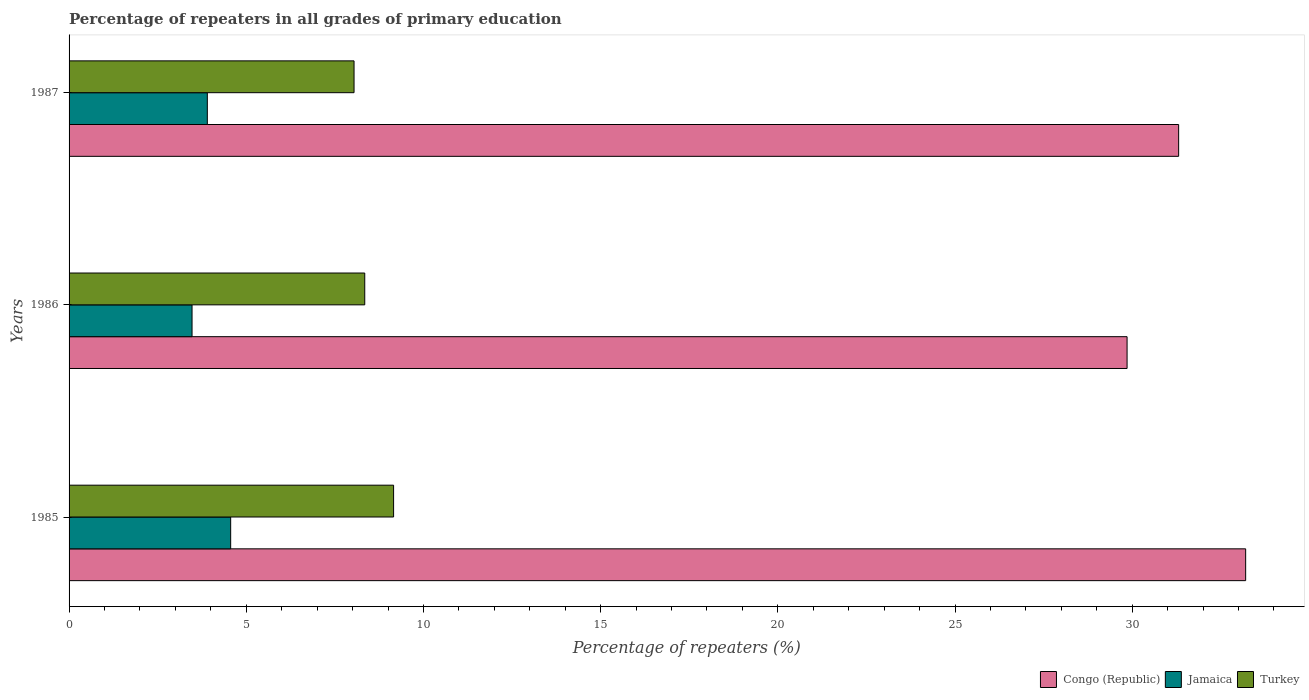How many groups of bars are there?
Provide a short and direct response. 3. Are the number of bars per tick equal to the number of legend labels?
Offer a terse response. Yes. In how many cases, is the number of bars for a given year not equal to the number of legend labels?
Your answer should be very brief. 0. What is the percentage of repeaters in Jamaica in 1986?
Give a very brief answer. 3.47. Across all years, what is the maximum percentage of repeaters in Turkey?
Give a very brief answer. 9.16. Across all years, what is the minimum percentage of repeaters in Turkey?
Offer a very short reply. 8.04. In which year was the percentage of repeaters in Turkey maximum?
Give a very brief answer. 1985. In which year was the percentage of repeaters in Congo (Republic) minimum?
Ensure brevity in your answer.  1986. What is the total percentage of repeaters in Jamaica in the graph?
Offer a terse response. 11.93. What is the difference between the percentage of repeaters in Congo (Republic) in 1986 and that in 1987?
Offer a very short reply. -1.46. What is the difference between the percentage of repeaters in Turkey in 1987 and the percentage of repeaters in Jamaica in 1986?
Your answer should be compact. 4.57. What is the average percentage of repeaters in Jamaica per year?
Offer a terse response. 3.98. In the year 1987, what is the difference between the percentage of repeaters in Turkey and percentage of repeaters in Jamaica?
Give a very brief answer. 4.14. In how many years, is the percentage of repeaters in Congo (Republic) greater than 22 %?
Your answer should be compact. 3. What is the ratio of the percentage of repeaters in Congo (Republic) in 1985 to that in 1986?
Your response must be concise. 1.11. What is the difference between the highest and the second highest percentage of repeaters in Congo (Republic)?
Provide a succinct answer. 1.89. What is the difference between the highest and the lowest percentage of repeaters in Jamaica?
Give a very brief answer. 1.09. What does the 1st bar from the top in 1987 represents?
Offer a terse response. Turkey. What does the 1st bar from the bottom in 1987 represents?
Your response must be concise. Congo (Republic). Is it the case that in every year, the sum of the percentage of repeaters in Turkey and percentage of repeaters in Congo (Republic) is greater than the percentage of repeaters in Jamaica?
Your answer should be compact. Yes. How many bars are there?
Your answer should be compact. 9. How many years are there in the graph?
Ensure brevity in your answer.  3. What is the difference between two consecutive major ticks on the X-axis?
Keep it short and to the point. 5. Does the graph contain any zero values?
Offer a terse response. No. Where does the legend appear in the graph?
Your answer should be compact. Bottom right. What is the title of the graph?
Provide a short and direct response. Percentage of repeaters in all grades of primary education. What is the label or title of the X-axis?
Your answer should be compact. Percentage of repeaters (%). What is the label or title of the Y-axis?
Make the answer very short. Years. What is the Percentage of repeaters (%) of Congo (Republic) in 1985?
Provide a succinct answer. 33.2. What is the Percentage of repeaters (%) in Jamaica in 1985?
Give a very brief answer. 4.56. What is the Percentage of repeaters (%) in Turkey in 1985?
Offer a very short reply. 9.16. What is the Percentage of repeaters (%) of Congo (Republic) in 1986?
Ensure brevity in your answer.  29.85. What is the Percentage of repeaters (%) of Jamaica in 1986?
Provide a short and direct response. 3.47. What is the Percentage of repeaters (%) in Turkey in 1986?
Give a very brief answer. 8.34. What is the Percentage of repeaters (%) of Congo (Republic) in 1987?
Keep it short and to the point. 31.31. What is the Percentage of repeaters (%) of Jamaica in 1987?
Make the answer very short. 3.9. What is the Percentage of repeaters (%) of Turkey in 1987?
Provide a short and direct response. 8.04. Across all years, what is the maximum Percentage of repeaters (%) of Congo (Republic)?
Provide a succinct answer. 33.2. Across all years, what is the maximum Percentage of repeaters (%) of Jamaica?
Offer a very short reply. 4.56. Across all years, what is the maximum Percentage of repeaters (%) in Turkey?
Offer a very short reply. 9.16. Across all years, what is the minimum Percentage of repeaters (%) of Congo (Republic)?
Give a very brief answer. 29.85. Across all years, what is the minimum Percentage of repeaters (%) of Jamaica?
Keep it short and to the point. 3.47. Across all years, what is the minimum Percentage of repeaters (%) in Turkey?
Make the answer very short. 8.04. What is the total Percentage of repeaters (%) of Congo (Republic) in the graph?
Provide a succinct answer. 94.37. What is the total Percentage of repeaters (%) in Jamaica in the graph?
Provide a succinct answer. 11.93. What is the total Percentage of repeaters (%) in Turkey in the graph?
Provide a succinct answer. 25.54. What is the difference between the Percentage of repeaters (%) of Congo (Republic) in 1985 and that in 1986?
Your response must be concise. 3.35. What is the difference between the Percentage of repeaters (%) of Jamaica in 1985 and that in 1986?
Provide a short and direct response. 1.09. What is the difference between the Percentage of repeaters (%) of Turkey in 1985 and that in 1986?
Give a very brief answer. 0.81. What is the difference between the Percentage of repeaters (%) in Congo (Republic) in 1985 and that in 1987?
Ensure brevity in your answer.  1.89. What is the difference between the Percentage of repeaters (%) of Jamaica in 1985 and that in 1987?
Your answer should be very brief. 0.66. What is the difference between the Percentage of repeaters (%) in Turkey in 1985 and that in 1987?
Provide a succinct answer. 1.12. What is the difference between the Percentage of repeaters (%) of Congo (Republic) in 1986 and that in 1987?
Offer a terse response. -1.46. What is the difference between the Percentage of repeaters (%) in Jamaica in 1986 and that in 1987?
Make the answer very short. -0.43. What is the difference between the Percentage of repeaters (%) of Turkey in 1986 and that in 1987?
Offer a very short reply. 0.3. What is the difference between the Percentage of repeaters (%) in Congo (Republic) in 1985 and the Percentage of repeaters (%) in Jamaica in 1986?
Keep it short and to the point. 29.73. What is the difference between the Percentage of repeaters (%) of Congo (Republic) in 1985 and the Percentage of repeaters (%) of Turkey in 1986?
Your answer should be very brief. 24.86. What is the difference between the Percentage of repeaters (%) in Jamaica in 1985 and the Percentage of repeaters (%) in Turkey in 1986?
Ensure brevity in your answer.  -3.78. What is the difference between the Percentage of repeaters (%) in Congo (Republic) in 1985 and the Percentage of repeaters (%) in Jamaica in 1987?
Give a very brief answer. 29.3. What is the difference between the Percentage of repeaters (%) of Congo (Republic) in 1985 and the Percentage of repeaters (%) of Turkey in 1987?
Provide a succinct answer. 25.16. What is the difference between the Percentage of repeaters (%) in Jamaica in 1985 and the Percentage of repeaters (%) in Turkey in 1987?
Offer a terse response. -3.48. What is the difference between the Percentage of repeaters (%) in Congo (Republic) in 1986 and the Percentage of repeaters (%) in Jamaica in 1987?
Ensure brevity in your answer.  25.95. What is the difference between the Percentage of repeaters (%) of Congo (Republic) in 1986 and the Percentage of repeaters (%) of Turkey in 1987?
Make the answer very short. 21.81. What is the difference between the Percentage of repeaters (%) of Jamaica in 1986 and the Percentage of repeaters (%) of Turkey in 1987?
Make the answer very short. -4.57. What is the average Percentage of repeaters (%) in Congo (Republic) per year?
Your answer should be compact. 31.46. What is the average Percentage of repeaters (%) of Jamaica per year?
Your answer should be very brief. 3.98. What is the average Percentage of repeaters (%) in Turkey per year?
Keep it short and to the point. 8.51. In the year 1985, what is the difference between the Percentage of repeaters (%) in Congo (Republic) and Percentage of repeaters (%) in Jamaica?
Give a very brief answer. 28.64. In the year 1985, what is the difference between the Percentage of repeaters (%) in Congo (Republic) and Percentage of repeaters (%) in Turkey?
Keep it short and to the point. 24.04. In the year 1985, what is the difference between the Percentage of repeaters (%) of Jamaica and Percentage of repeaters (%) of Turkey?
Your response must be concise. -4.6. In the year 1986, what is the difference between the Percentage of repeaters (%) in Congo (Republic) and Percentage of repeaters (%) in Jamaica?
Make the answer very short. 26.38. In the year 1986, what is the difference between the Percentage of repeaters (%) in Congo (Republic) and Percentage of repeaters (%) in Turkey?
Offer a very short reply. 21.51. In the year 1986, what is the difference between the Percentage of repeaters (%) of Jamaica and Percentage of repeaters (%) of Turkey?
Offer a terse response. -4.87. In the year 1987, what is the difference between the Percentage of repeaters (%) of Congo (Republic) and Percentage of repeaters (%) of Jamaica?
Keep it short and to the point. 27.41. In the year 1987, what is the difference between the Percentage of repeaters (%) in Congo (Republic) and Percentage of repeaters (%) in Turkey?
Give a very brief answer. 23.27. In the year 1987, what is the difference between the Percentage of repeaters (%) in Jamaica and Percentage of repeaters (%) in Turkey?
Your response must be concise. -4.14. What is the ratio of the Percentage of repeaters (%) in Congo (Republic) in 1985 to that in 1986?
Offer a terse response. 1.11. What is the ratio of the Percentage of repeaters (%) in Jamaica in 1985 to that in 1986?
Keep it short and to the point. 1.31. What is the ratio of the Percentage of repeaters (%) in Turkey in 1985 to that in 1986?
Offer a very short reply. 1.1. What is the ratio of the Percentage of repeaters (%) in Congo (Republic) in 1985 to that in 1987?
Keep it short and to the point. 1.06. What is the ratio of the Percentage of repeaters (%) in Jamaica in 1985 to that in 1987?
Offer a terse response. 1.17. What is the ratio of the Percentage of repeaters (%) in Turkey in 1985 to that in 1987?
Offer a terse response. 1.14. What is the ratio of the Percentage of repeaters (%) in Congo (Republic) in 1986 to that in 1987?
Your response must be concise. 0.95. What is the ratio of the Percentage of repeaters (%) of Jamaica in 1986 to that in 1987?
Provide a succinct answer. 0.89. What is the ratio of the Percentage of repeaters (%) in Turkey in 1986 to that in 1987?
Provide a succinct answer. 1.04. What is the difference between the highest and the second highest Percentage of repeaters (%) in Congo (Republic)?
Keep it short and to the point. 1.89. What is the difference between the highest and the second highest Percentage of repeaters (%) in Jamaica?
Provide a succinct answer. 0.66. What is the difference between the highest and the second highest Percentage of repeaters (%) in Turkey?
Offer a very short reply. 0.81. What is the difference between the highest and the lowest Percentage of repeaters (%) in Congo (Republic)?
Offer a terse response. 3.35. What is the difference between the highest and the lowest Percentage of repeaters (%) of Jamaica?
Your answer should be very brief. 1.09. What is the difference between the highest and the lowest Percentage of repeaters (%) in Turkey?
Make the answer very short. 1.12. 